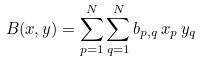Convert formula to latex. <formula><loc_0><loc_0><loc_500><loc_500>B ( x , y ) = \sum _ { p = 1 } ^ { N } \sum _ { q = 1 } ^ { N } b _ { p , q } \, x _ { p } \, y _ { q }</formula> 